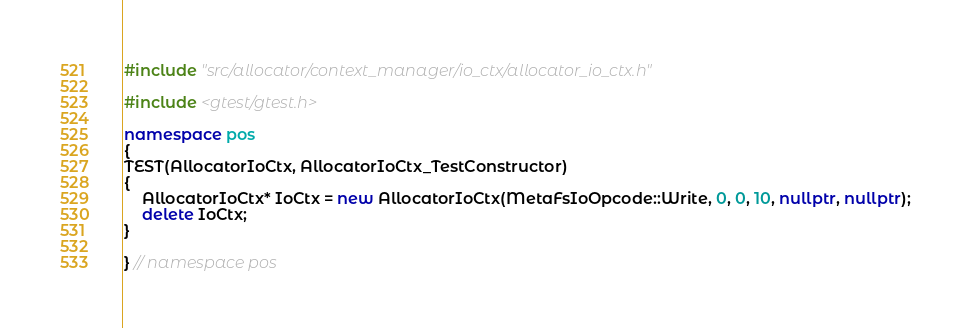<code> <loc_0><loc_0><loc_500><loc_500><_C++_>#include "src/allocator/context_manager/io_ctx/allocator_io_ctx.h"

#include <gtest/gtest.h>

namespace pos
{
TEST(AllocatorIoCtx, AllocatorIoCtx_TestConstructor)
{
    AllocatorIoCtx* IoCtx = new AllocatorIoCtx(MetaFsIoOpcode::Write, 0, 0, 10, nullptr, nullptr);
    delete IoCtx;
}

} // namespace pos
</code> 